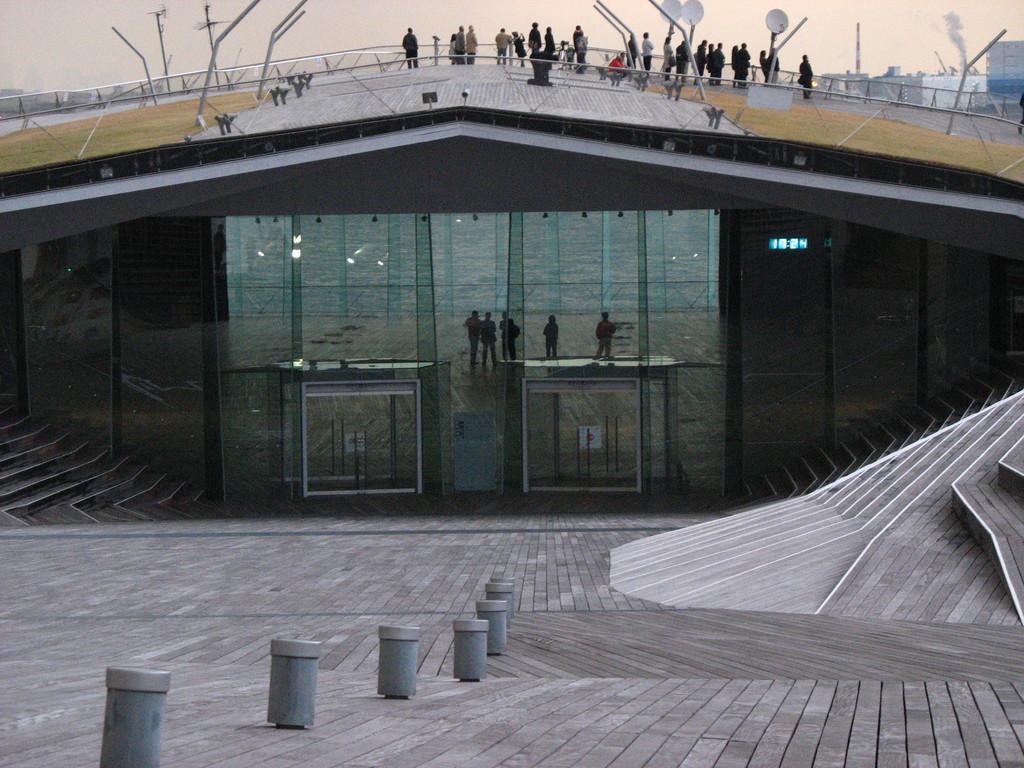Could you give a brief overview of what you see in this image? We can see poles, steps, building and glass. Top of the building we can see people, poles and dish antenna, through this glass we can see people. In the background we can see sky and smoke. 